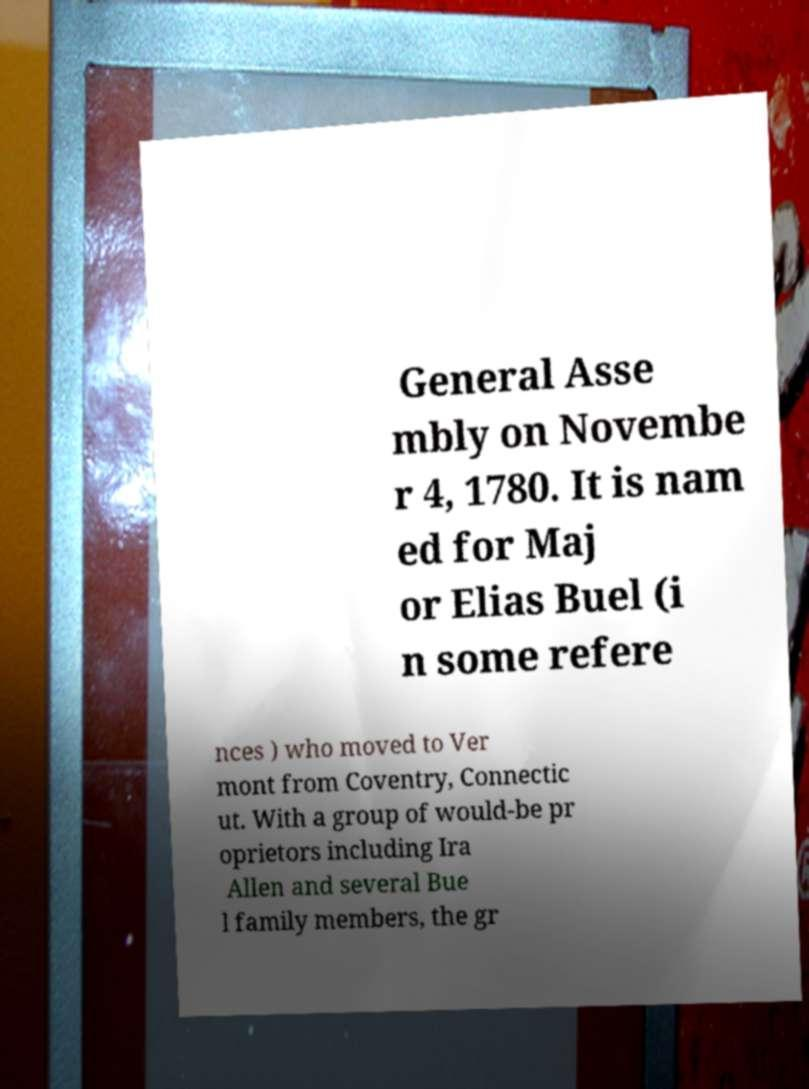What messages or text are displayed in this image? I need them in a readable, typed format. General Asse mbly on Novembe r 4, 1780. It is nam ed for Maj or Elias Buel (i n some refere nces ) who moved to Ver mont from Coventry, Connectic ut. With a group of would-be pr oprietors including Ira Allen and several Bue l family members, the gr 